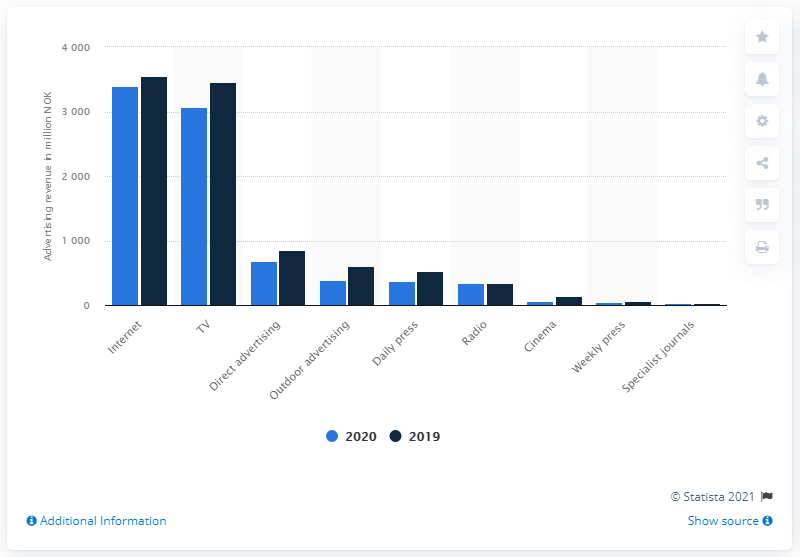Give some essential details in this illustration. The internet's ad spending in Norway in 2020 was 3395.11. 